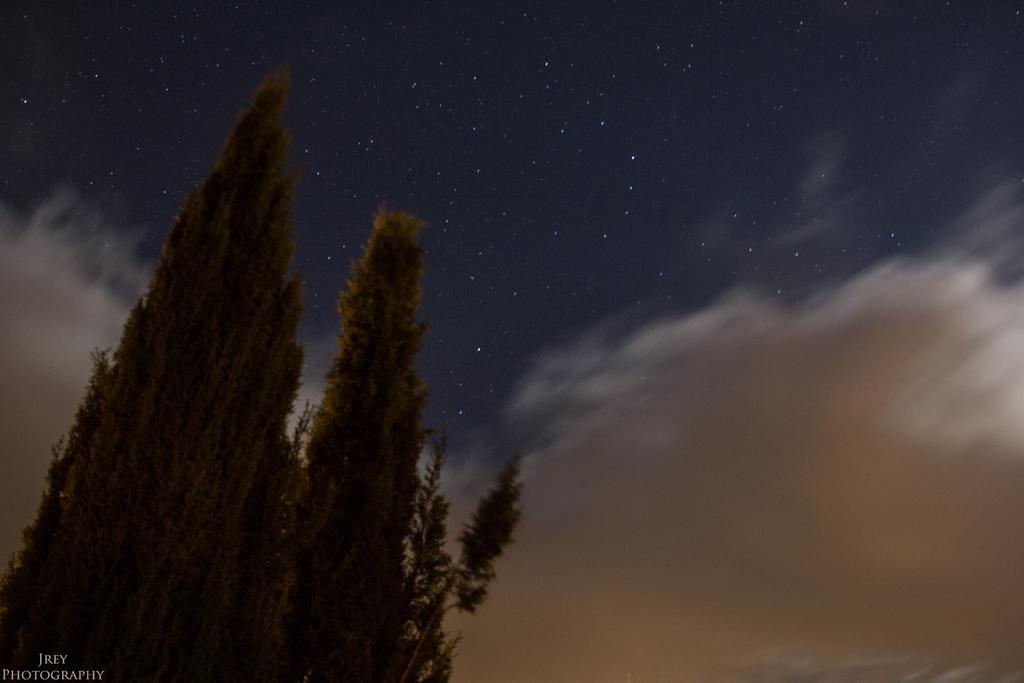How would you summarize this image in a sentence or two? In this image on the left there are trees. The sky is cloud. There are stars in the sky. 